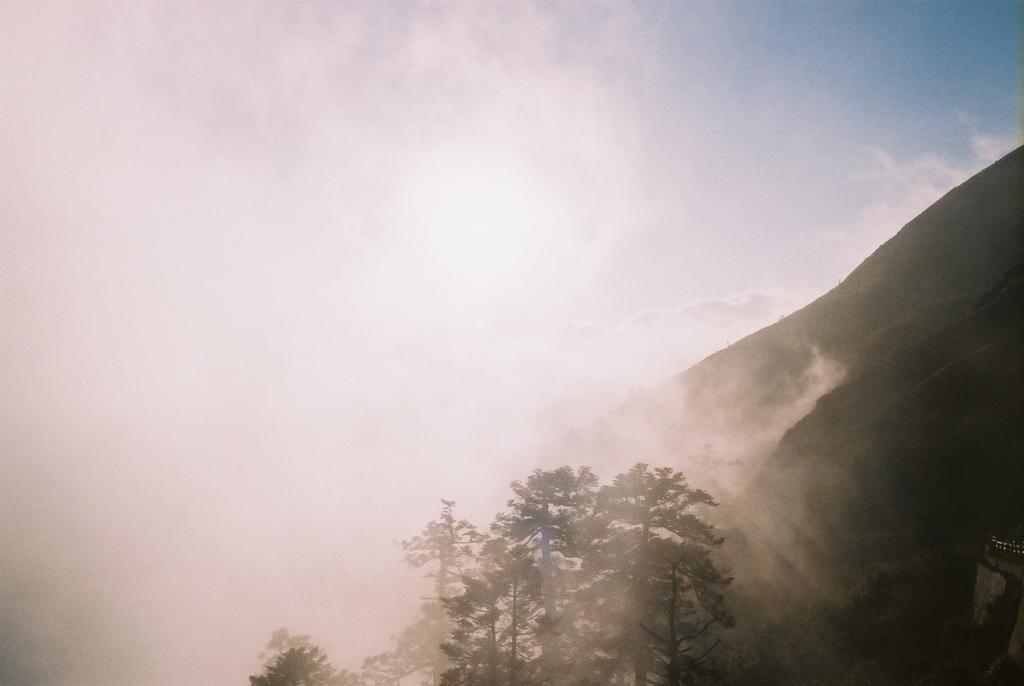What type of natural features can be seen in the image? There are trees and mountains in the image. What atmospheric condition is present in the image? There is fog in the image. What color is the sky in the image? The sky is blue in color. What type of building can be seen in the image? There is no building present in the image; it features trees, mountains, fog, and a blue sky. What sounds can be heard in the image? The image is silent, as it is a still picture, and therefore no sounds can be heard. 